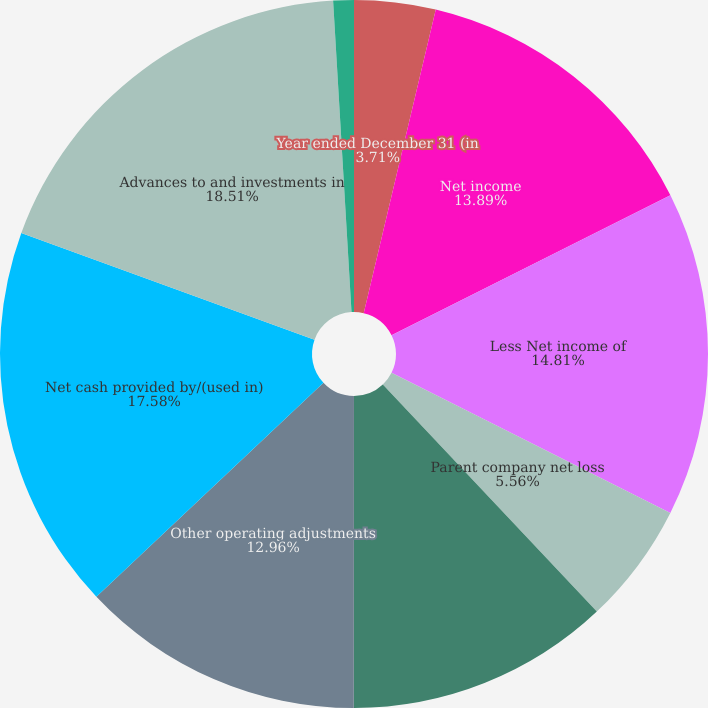Convert chart to OTSL. <chart><loc_0><loc_0><loc_500><loc_500><pie_chart><fcel>Year ended December 31 (in<fcel>Net income<fcel>Less Net income of<fcel>Parent company net loss<fcel>Cash dividends from<fcel>Other operating adjustments<fcel>Net cash provided by/(used in)<fcel>Advances to and investments in<fcel>All other investing activities<nl><fcel>3.71%<fcel>13.89%<fcel>14.81%<fcel>5.56%<fcel>12.04%<fcel>12.96%<fcel>17.58%<fcel>18.51%<fcel>0.94%<nl></chart> 